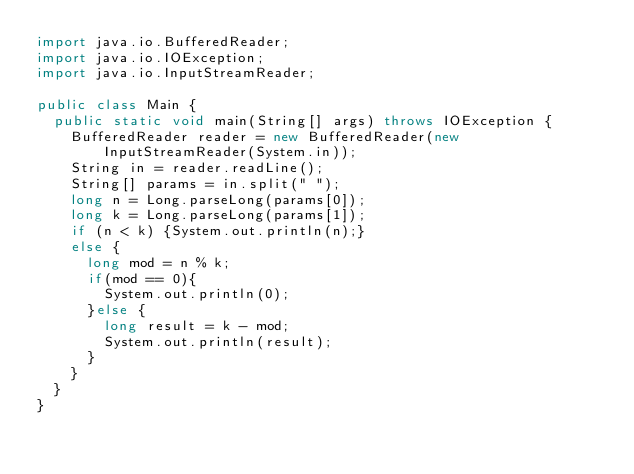<code> <loc_0><loc_0><loc_500><loc_500><_Java_>import java.io.BufferedReader;
import java.io.IOException;
import java.io.InputStreamReader;

public class Main {
  public static void main(String[] args) throws IOException {
    BufferedReader reader = new BufferedReader(new InputStreamReader(System.in));
    String in = reader.readLine();
    String[] params = in.split(" ");
    long n = Long.parseLong(params[0]);
    long k = Long.parseLong(params[1]);
    if (n < k) {System.out.println(n);}
    else {
      long mod = n % k;
      if(mod == 0){
        System.out.println(0);
      }else {
        long result = k - mod;
        System.out.println(result);
      }
    }
  }
}
</code> 